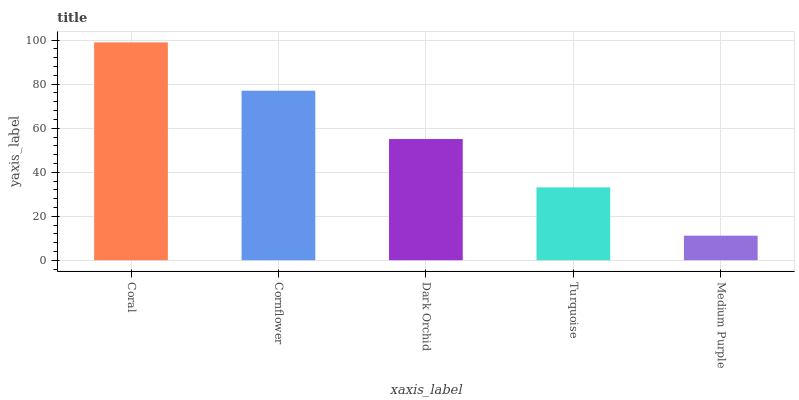Is Medium Purple the minimum?
Answer yes or no. Yes. Is Coral the maximum?
Answer yes or no. Yes. Is Cornflower the minimum?
Answer yes or no. No. Is Cornflower the maximum?
Answer yes or no. No. Is Coral greater than Cornflower?
Answer yes or no. Yes. Is Cornflower less than Coral?
Answer yes or no. Yes. Is Cornflower greater than Coral?
Answer yes or no. No. Is Coral less than Cornflower?
Answer yes or no. No. Is Dark Orchid the high median?
Answer yes or no. Yes. Is Dark Orchid the low median?
Answer yes or no. Yes. Is Turquoise the high median?
Answer yes or no. No. Is Cornflower the low median?
Answer yes or no. No. 